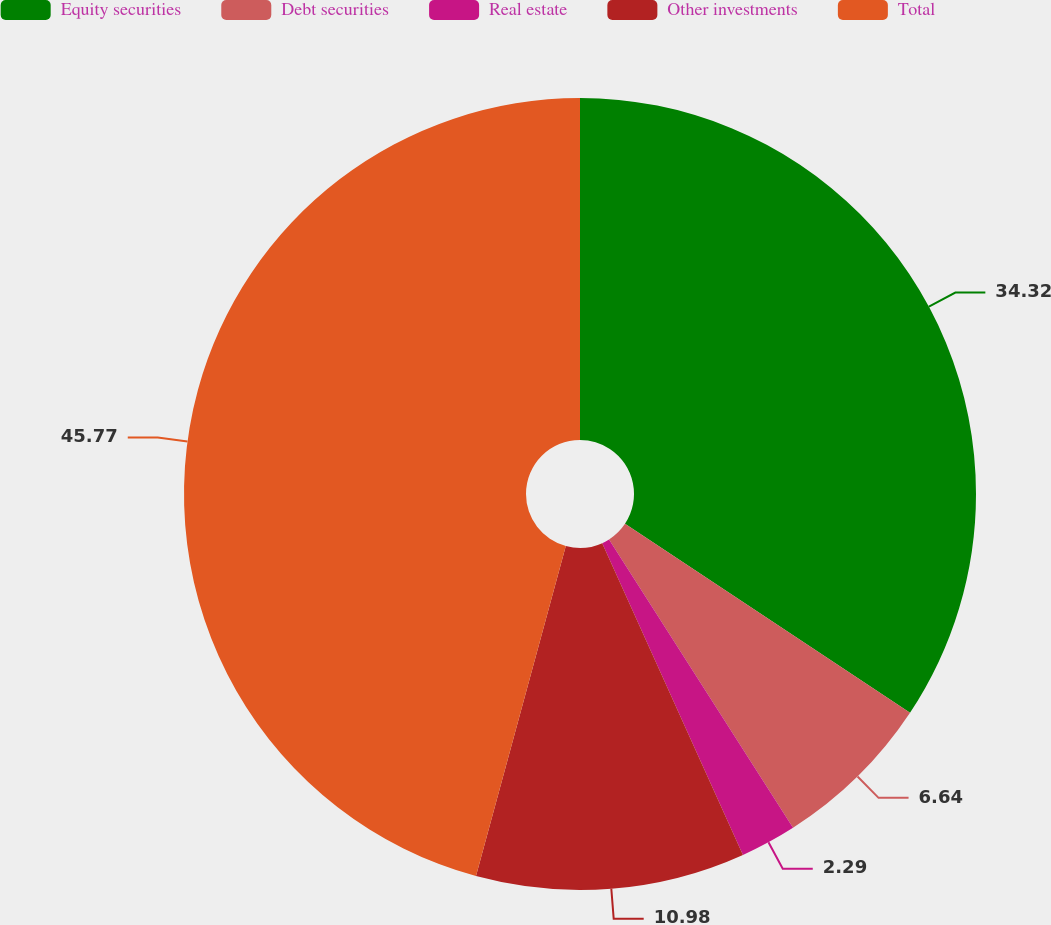<chart> <loc_0><loc_0><loc_500><loc_500><pie_chart><fcel>Equity securities<fcel>Debt securities<fcel>Real estate<fcel>Other investments<fcel>Total<nl><fcel>34.32%<fcel>6.64%<fcel>2.29%<fcel>10.98%<fcel>45.77%<nl></chart> 